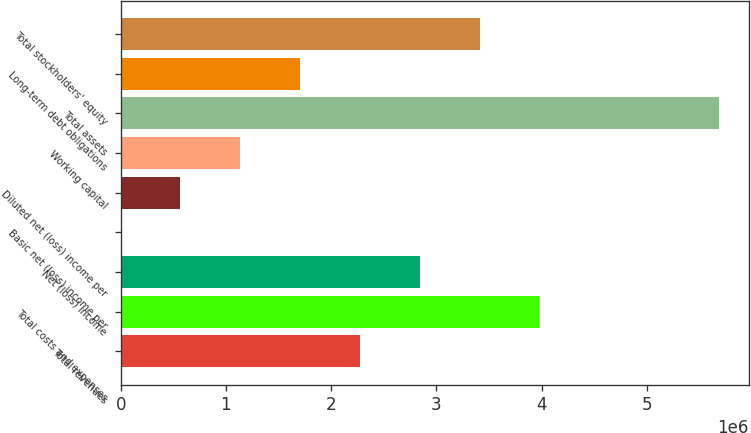Convert chart to OTSL. <chart><loc_0><loc_0><loc_500><loc_500><bar_chart><fcel>Total revenues<fcel>Total costs and expenses<fcel>Net (loss) income<fcel>Basic net (loss) income per<fcel>Diluted net (loss) income per<fcel>Working capital<fcel>Total assets<fcel>Long-term debt obligations<fcel>Total stockholders' equity<nl><fcel>2.2737e+06<fcel>3.97896e+06<fcel>2.84212e+06<fcel>8.64<fcel>568430<fcel>1.13685e+06<fcel>5.68423e+06<fcel>1.70527e+06<fcel>3.41054e+06<nl></chart> 